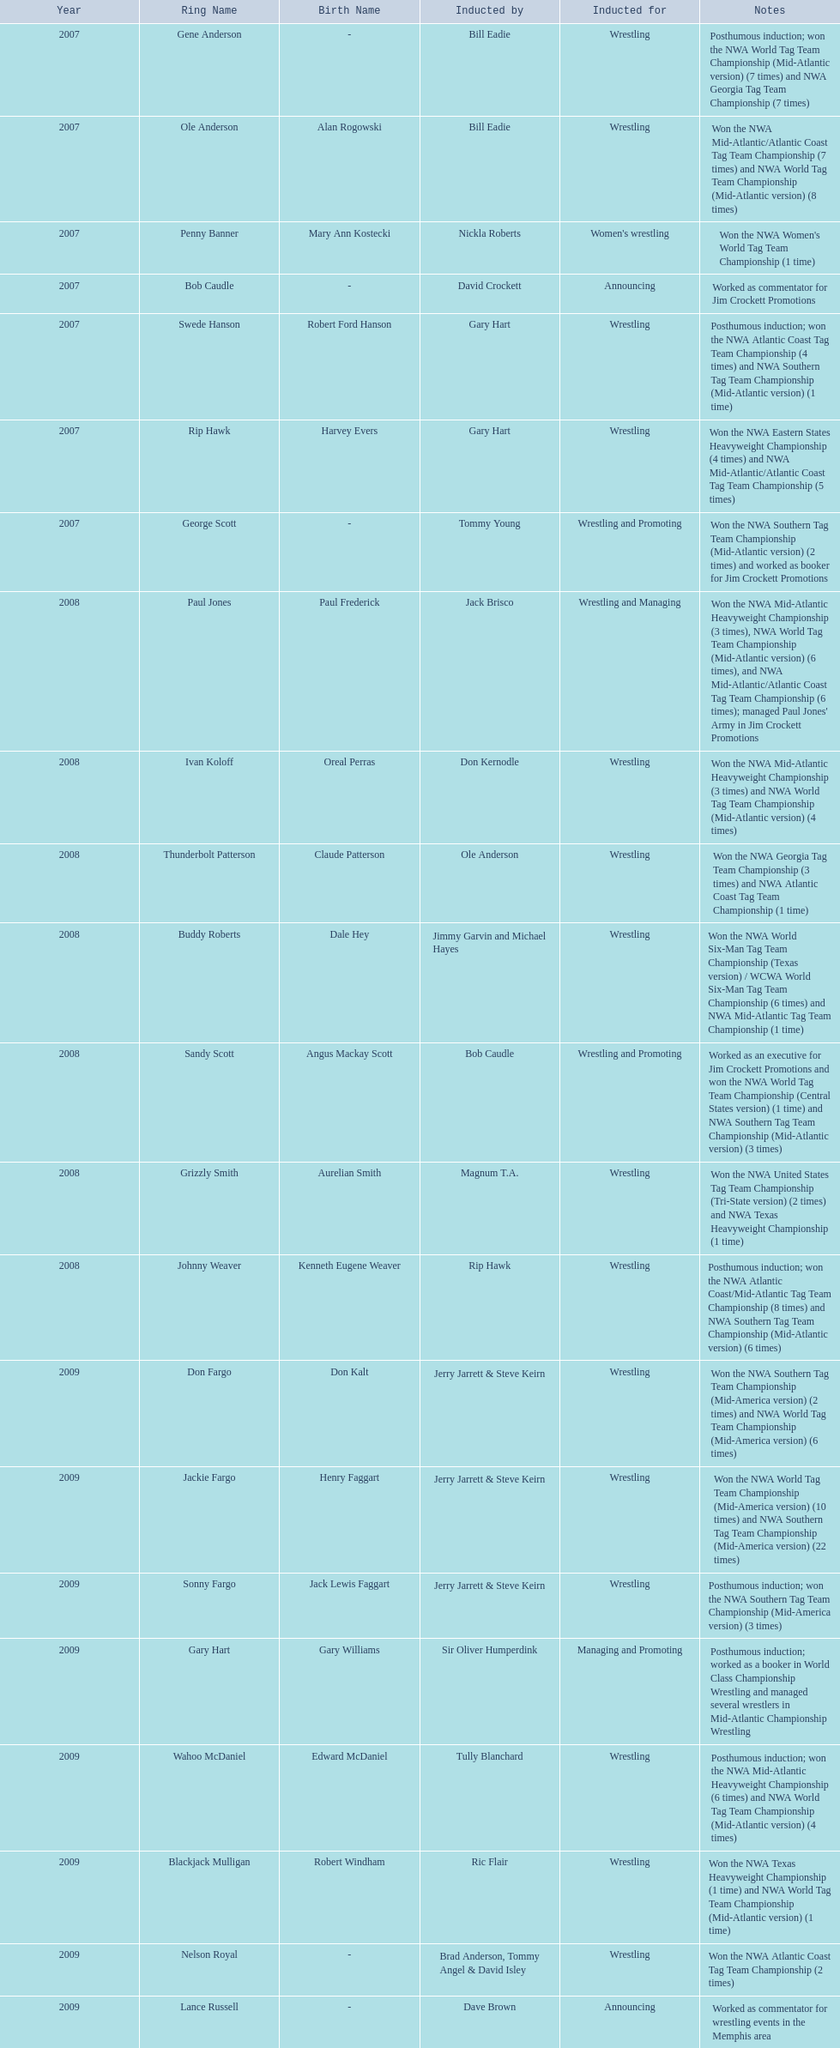Find the word(s) posthumous in the notes column. Posthumous induction; won the NWA World Tag Team Championship (Mid-Atlantic version) (7 times) and NWA Georgia Tag Team Championship (7 times), Posthumous induction; won the NWA Atlantic Coast Tag Team Championship (4 times) and NWA Southern Tag Team Championship (Mid-Atlantic version) (1 time), Posthumous induction; won the NWA Atlantic Coast/Mid-Atlantic Tag Team Championship (8 times) and NWA Southern Tag Team Championship (Mid-Atlantic version) (6 times), Posthumous induction; won the NWA Southern Tag Team Championship (Mid-America version) (3 times), Posthumous induction; worked as a booker in World Class Championship Wrestling and managed several wrestlers in Mid-Atlantic Championship Wrestling, Posthumous induction; won the NWA Mid-Atlantic Heavyweight Championship (6 times) and NWA World Tag Team Championship (Mid-Atlantic version) (4 times). What is the earliest year in the table that wrestlers were inducted? 2007, 2007, 2007, 2007, 2007, 2007, 2007. Find the wrestlers that wrestled underneath their birth name in the earliest year of induction. Gene Anderson, Bob Caudle, George Scott. Of the wrestlers who wrestled underneath their birth name in the earliest year of induction was one of them inducted posthumously? Gene Anderson. 